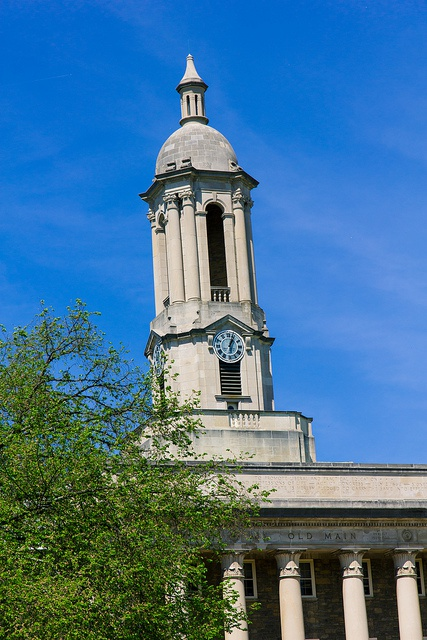Describe the objects in this image and their specific colors. I can see a clock in blue, gray, darkgray, lightgray, and black tones in this image. 